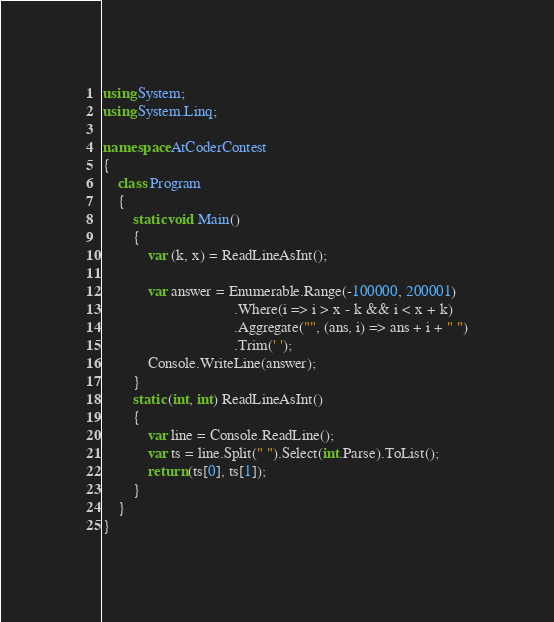Convert code to text. <code><loc_0><loc_0><loc_500><loc_500><_C#_>using System;
using System.Linq;

namespace AtCoderContest
{
    class Program
    {
        static void Main()
        {
            var (k, x) = ReadLineAsInt();

            var answer = Enumerable.Range(-100000, 200001)
                                   .Where(i => i > x - k && i < x + k)
                                   .Aggregate("", (ans, i) => ans + i + " ")
                                   .Trim(' ');
            Console.WriteLine(answer);
        }
        static (int, int) ReadLineAsInt()
        {
            var line = Console.ReadLine();
            var ts = line.Split(" ").Select(int.Parse).ToList();
            return (ts[0], ts[1]);
        }
    }
}
</code> 